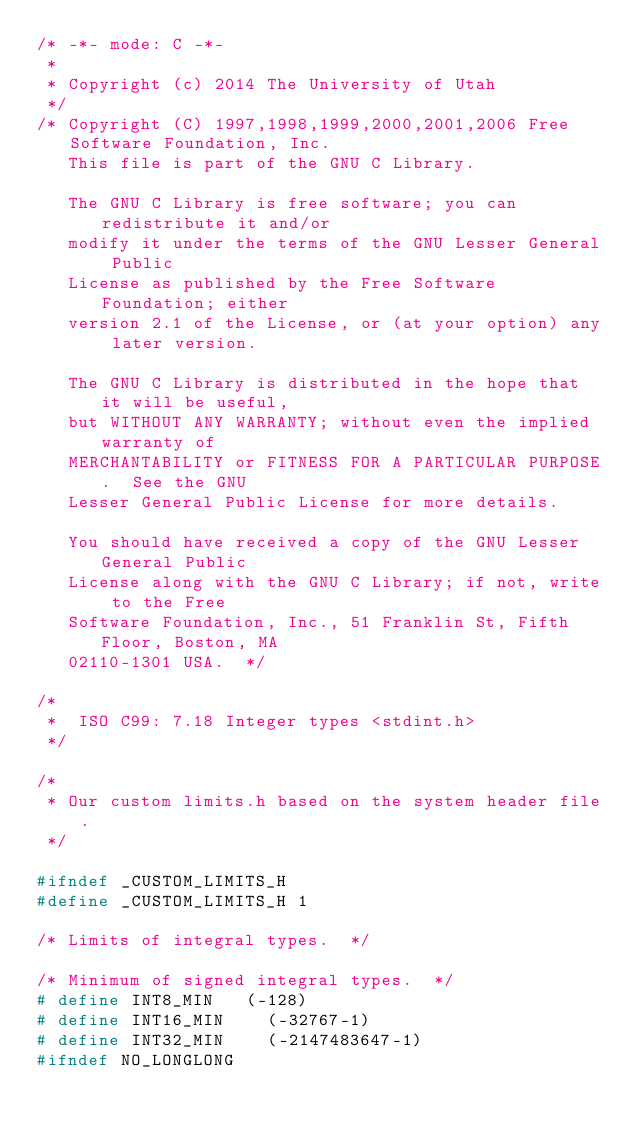<code> <loc_0><loc_0><loc_500><loc_500><_C_>/* -*- mode: C -*-
 *
 * Copyright (c) 2014 The University of Utah
 */
/* Copyright (C) 1997,1998,1999,2000,2001,2006 Free Software Foundation, Inc.
   This file is part of the GNU C Library.

   The GNU C Library is free software; you can redistribute it and/or
   modify it under the terms of the GNU Lesser General Public
   License as published by the Free Software Foundation; either
   version 2.1 of the License, or (at your option) any later version.

   The GNU C Library is distributed in the hope that it will be useful,
   but WITHOUT ANY WARRANTY; without even the implied warranty of
   MERCHANTABILITY or FITNESS FOR A PARTICULAR PURPOSE.  See the GNU
   Lesser General Public License for more details.

   You should have received a copy of the GNU Lesser General Public
   License along with the GNU C Library; if not, write to the Free
   Software Foundation, Inc., 51 Franklin St, Fifth Floor, Boston, MA
   02110-1301 USA.  */

/*
 *	ISO C99: 7.18 Integer types <stdint.h>
 */

/*
 * Our custom limits.h based on the system header file.
 */

#ifndef _CUSTOM_LIMITS_H
#define _CUSTOM_LIMITS_H 1

/* Limits of integral types.  */

/* Minimum of signed integral types.  */
# define INT8_MIN		(-128)
# define INT16_MIN		(-32767-1)
# define INT32_MIN		(-2147483647-1)
#ifndef NO_LONGLONG</code> 